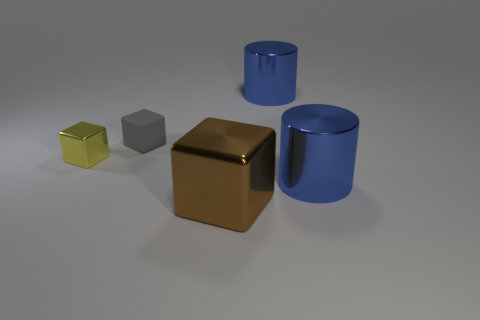Is there anything else that is the same material as the tiny gray object?
Offer a terse response. No. There is a shiny block that is on the left side of the metal block right of the tiny shiny object; is there a cylinder that is in front of it?
Offer a terse response. Yes. There is a brown metallic object; is its shape the same as the big blue metal thing in front of the small metal block?
Your response must be concise. No. Is there anything else that has the same color as the small metallic cube?
Keep it short and to the point. No. Is the color of the shiny block that is on the right side of the gray matte cube the same as the shiny cube that is behind the big brown metal block?
Offer a terse response. No. Is there a purple sphere?
Keep it short and to the point. No. Are there any big gray balls made of the same material as the large cube?
Your answer should be compact. No. The rubber block has what color?
Provide a short and direct response. Gray. The other cube that is the same size as the yellow cube is what color?
Keep it short and to the point. Gray. What number of rubber things are either large brown objects or small cubes?
Your response must be concise. 1. 